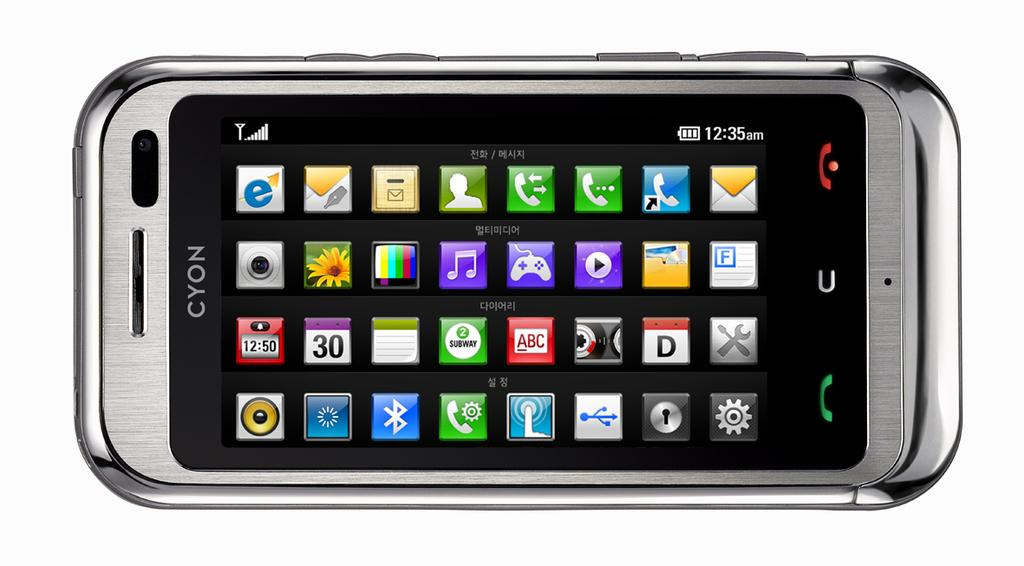<image>
Relay a brief, clear account of the picture shown. an old looking phone with the word cyon along the top 